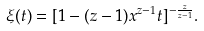<formula> <loc_0><loc_0><loc_500><loc_500>\xi ( t ) = [ 1 - ( z - 1 ) x ^ { z - 1 } t ] ^ { - \frac { z } { z - 1 } } .</formula> 